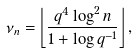Convert formula to latex. <formula><loc_0><loc_0><loc_500><loc_500>\nu _ { n } = \left \lfloor \frac { q ^ { 4 } \log ^ { 2 } n } { 1 + \log q ^ { - 1 } } \right \rfloor ,</formula> 